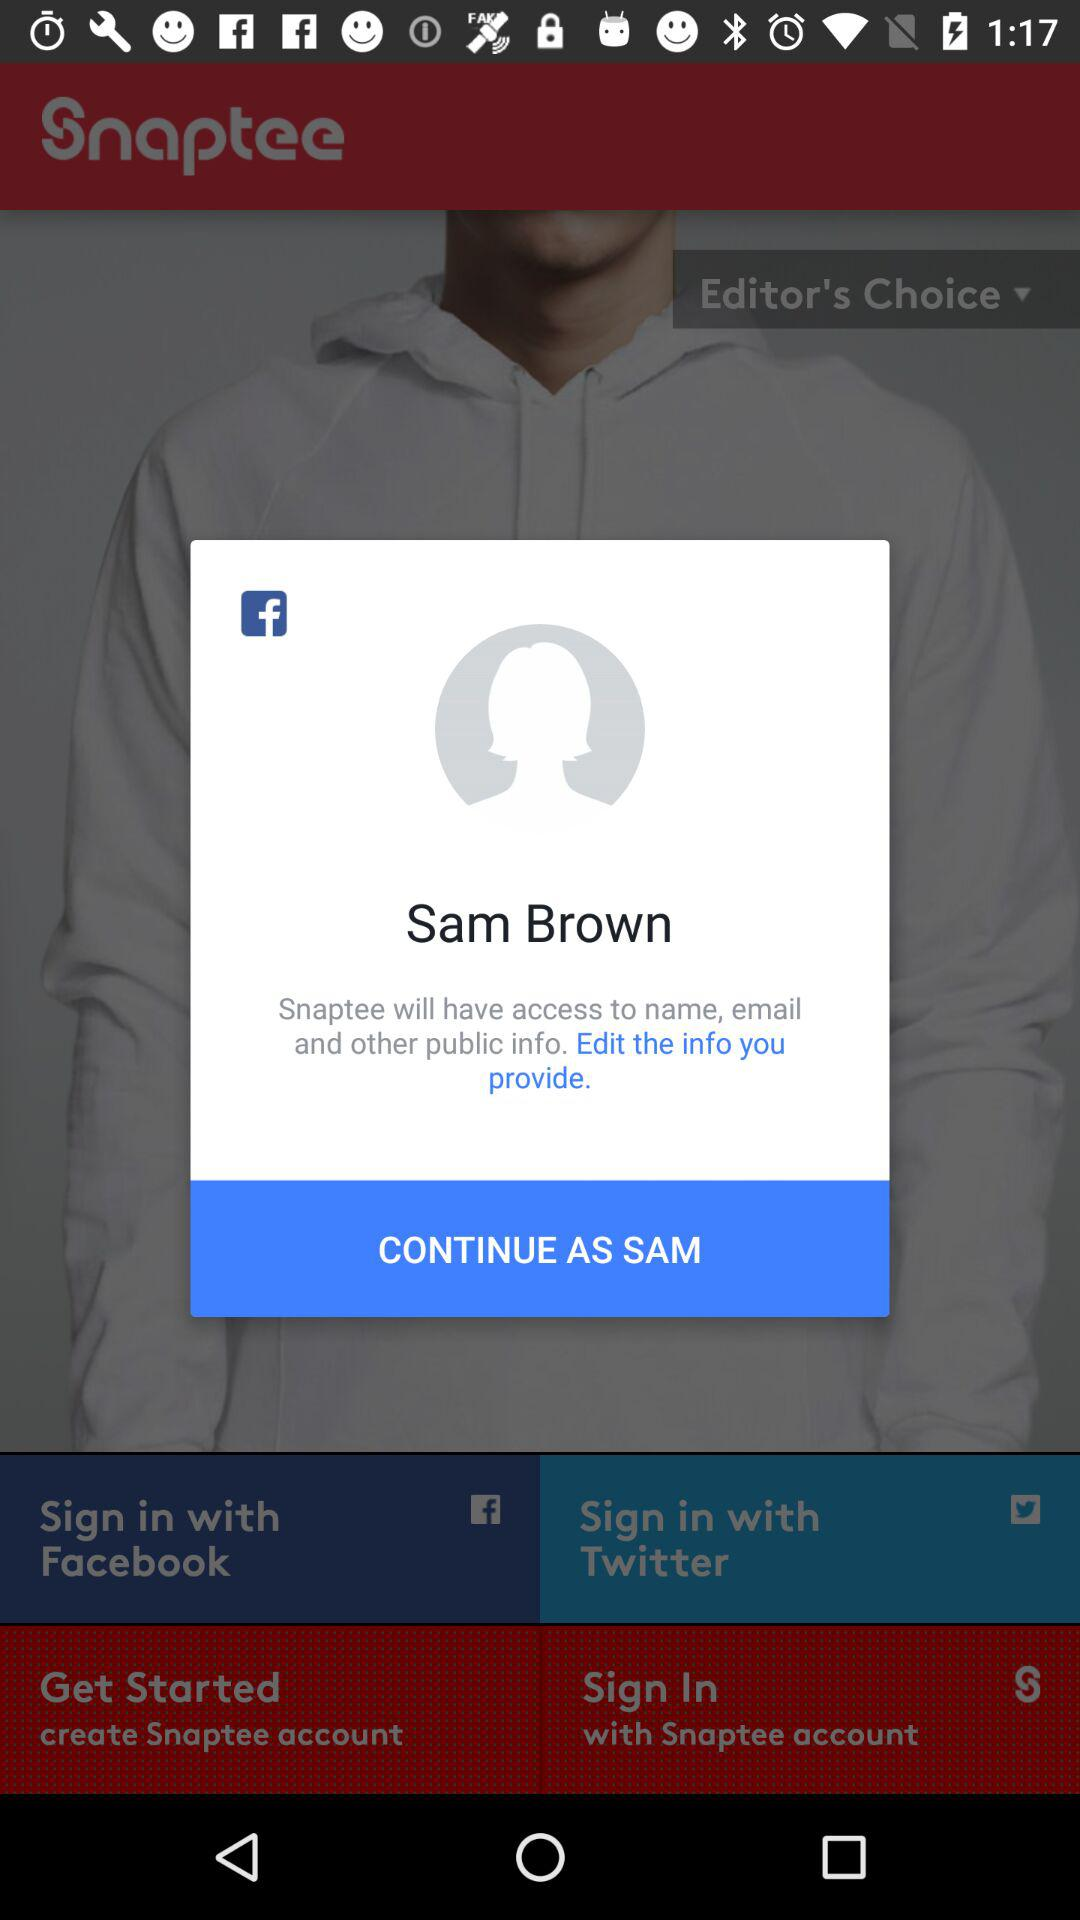What is the user name? The user name is Sam Brown. 